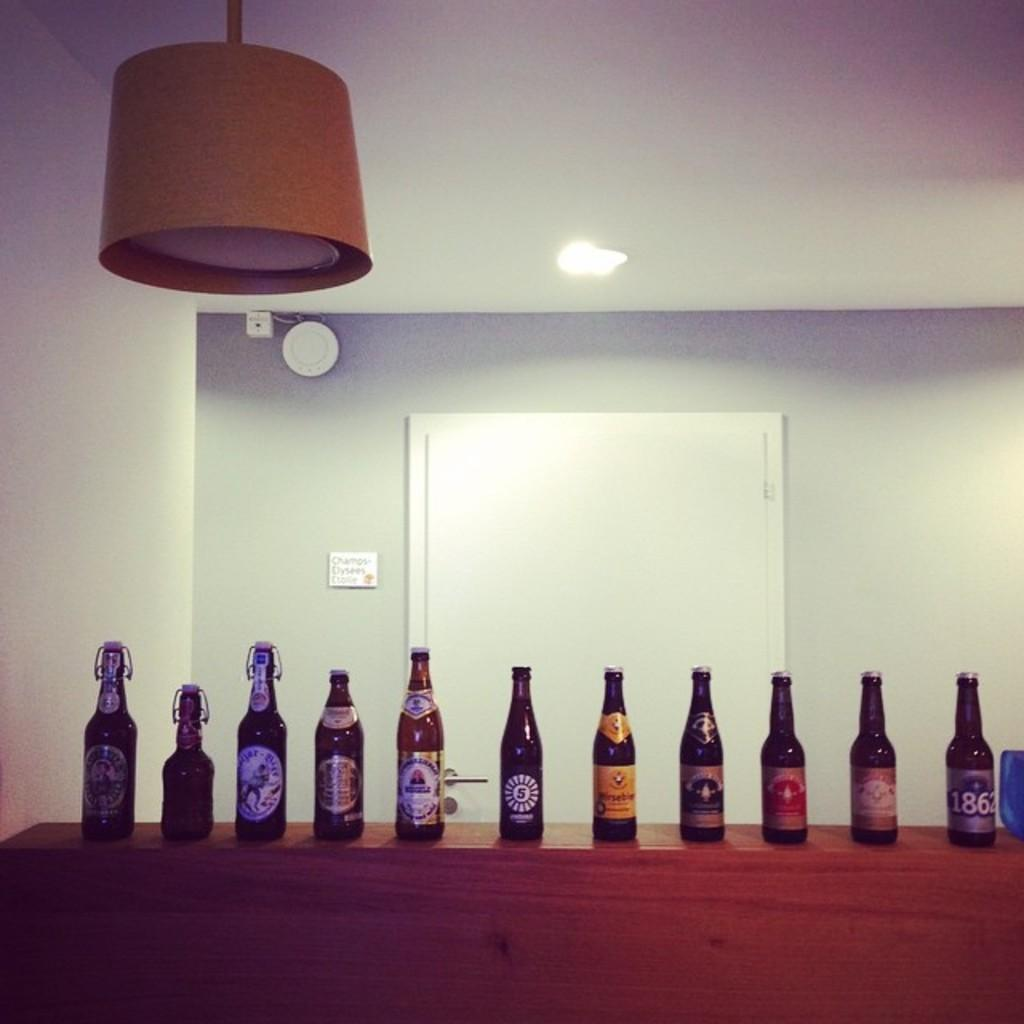<image>
Share a concise interpretation of the image provided. Many beer bottles on display including one from the year 1862. 